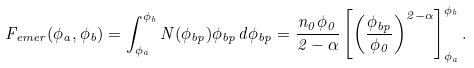Convert formula to latex. <formula><loc_0><loc_0><loc_500><loc_500>F _ { e m e r } ( \phi _ { a } , \phi _ { b } ) = \int _ { \phi _ { a } } ^ { \phi _ { b } } N ( \phi _ { b p } ) \phi _ { b p } d \phi _ { b p } = \frac { n _ { 0 } \phi _ { 0 } } { 2 - \alpha } \left [ \left ( \frac { \phi _ { b p } } { \phi _ { 0 } } \right ) ^ { 2 - \alpha } \right ] _ { \phi _ { a } } ^ { \phi _ { b } } .</formula> 